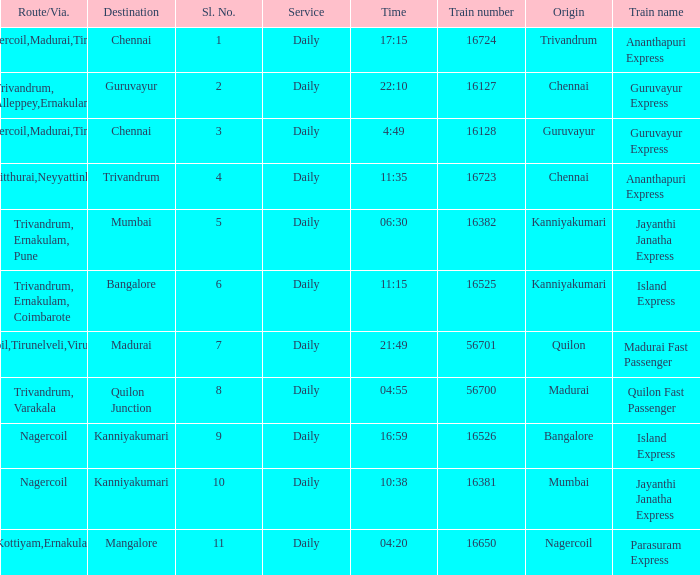What is the origin when the destination is Mumbai? Kanniyakumari. 